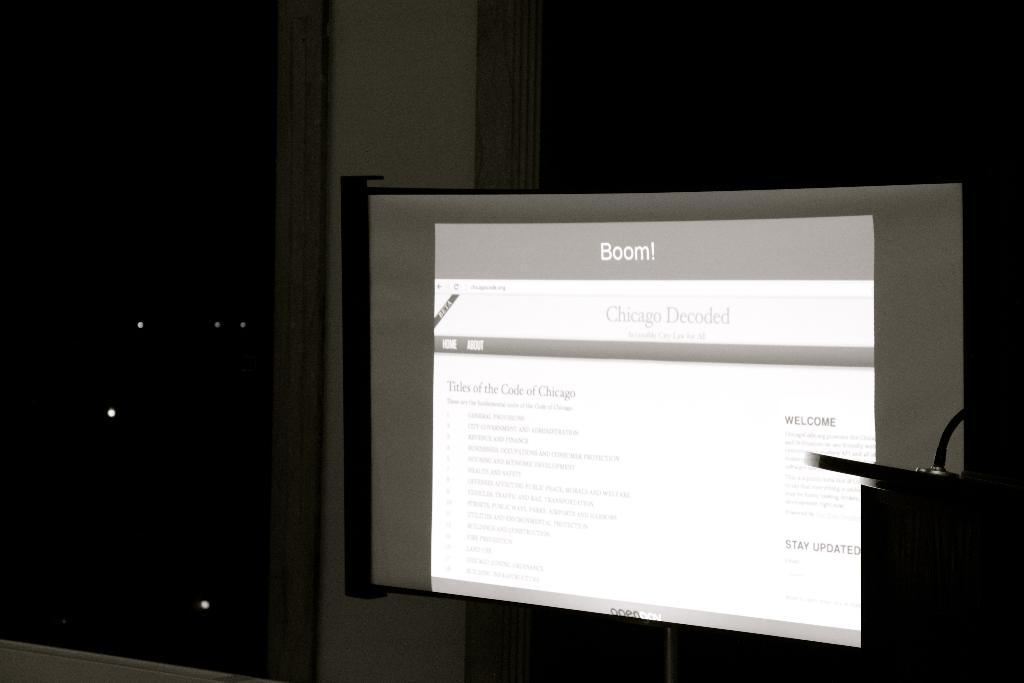Provide a one-sentence caption for the provided image. A picture of a computer monitor with a "Chicago Decoded" blog shown on it. 